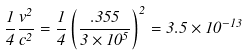Convert formula to latex. <formula><loc_0><loc_0><loc_500><loc_500>\frac { 1 } { 4 } \frac { v ^ { 2 } } { c ^ { 2 } } = \frac { 1 } { 4 } \left ( { \frac { . 3 5 5 } { 3 \times 1 0 ^ { 5 } } } \right ) ^ { 2 } = 3 . 5 \times 1 0 ^ { - 1 3 }</formula> 